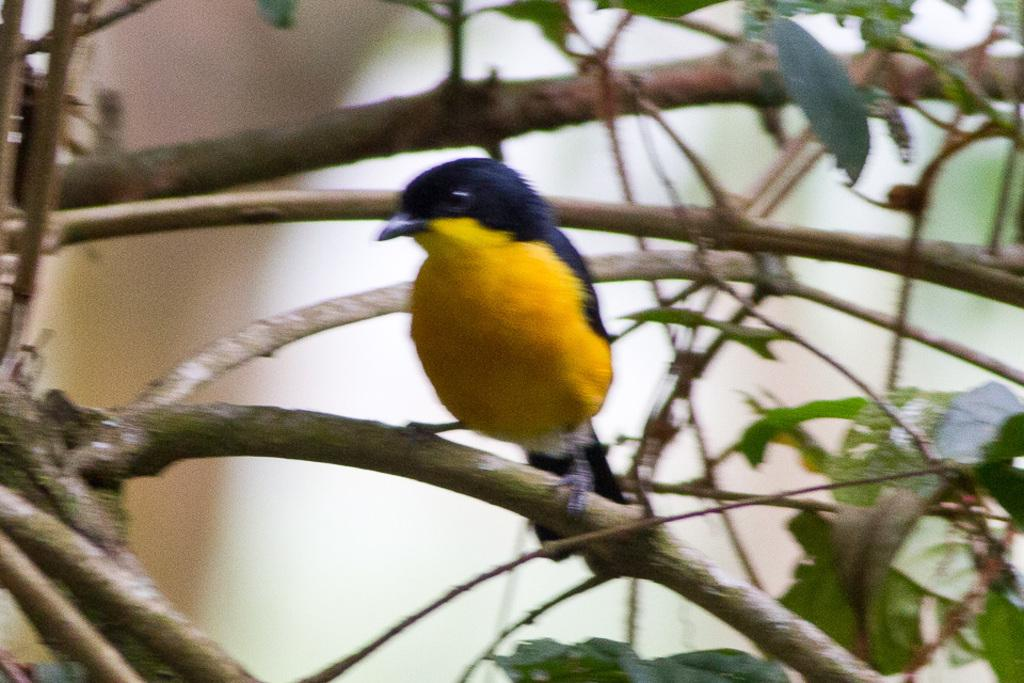What type of animal can be seen in the image? There is a bird in the image, possibly on a tree branch. What is the bird perched on in the image? The image shows branches, so the bird may be perched on a tree branch. What other plant-related elements are visible in the image? In addition to branches, there are stems and leaves in the image. What grade did the bird receive on its recent test in the image? There is no indication of a test or grade in the image; it features a bird on a tree branch with surrounding plant elements. 